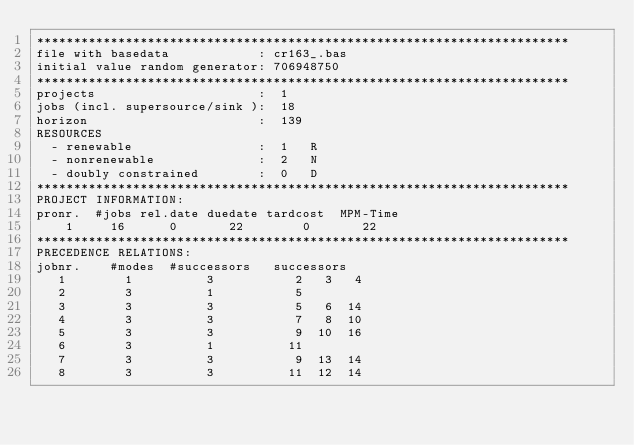<code> <loc_0><loc_0><loc_500><loc_500><_ObjectiveC_>************************************************************************
file with basedata            : cr163_.bas
initial value random generator: 706948750
************************************************************************
projects                      :  1
jobs (incl. supersource/sink ):  18
horizon                       :  139
RESOURCES
  - renewable                 :  1   R
  - nonrenewable              :  2   N
  - doubly constrained        :  0   D
************************************************************************
PROJECT INFORMATION:
pronr.  #jobs rel.date duedate tardcost  MPM-Time
    1     16      0       22        0       22
************************************************************************
PRECEDENCE RELATIONS:
jobnr.    #modes  #successors   successors
   1        1          3           2   3   4
   2        3          1           5
   3        3          3           5   6  14
   4        3          3           7   8  10
   5        3          3           9  10  16
   6        3          1          11
   7        3          3           9  13  14
   8        3          3          11  12  14</code> 